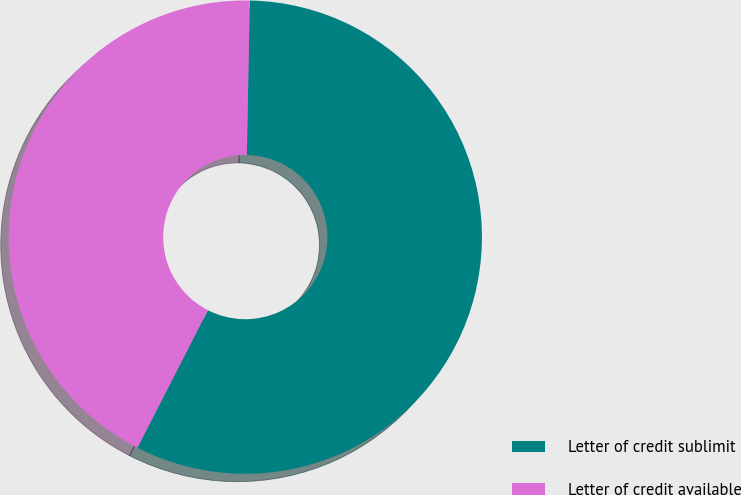<chart> <loc_0><loc_0><loc_500><loc_500><pie_chart><fcel>Letter of credit sublimit<fcel>Letter of credit available<nl><fcel>57.23%<fcel>42.77%<nl></chart> 